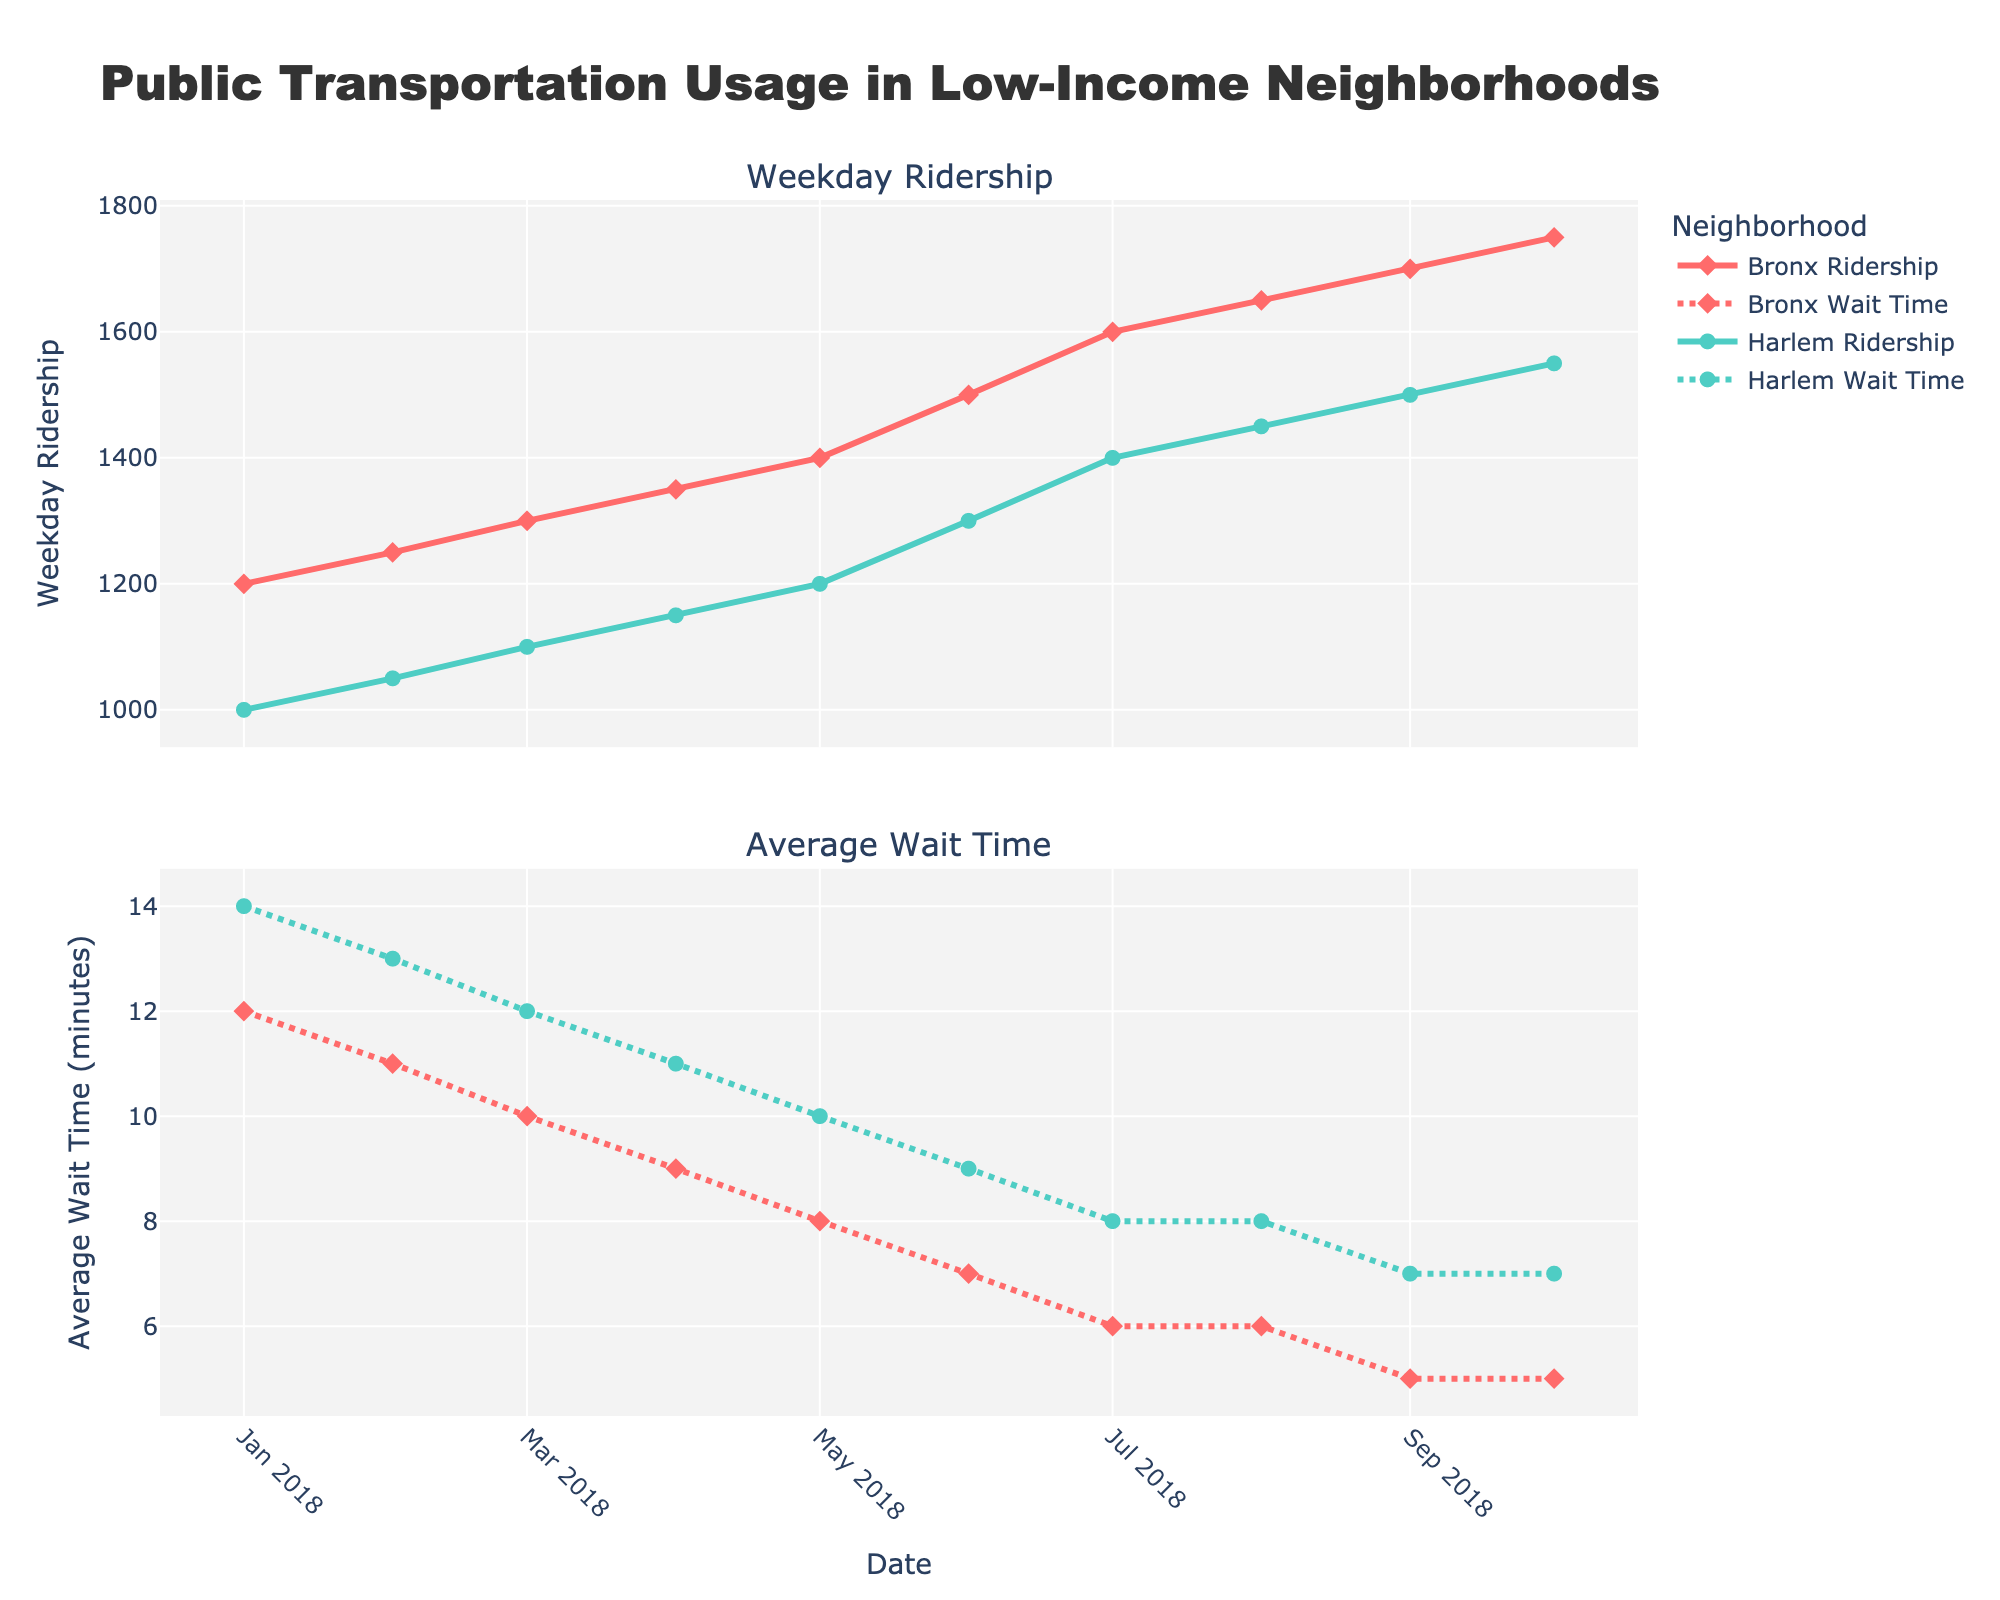What is the title of the plot? The title of the plot is displayed at the top of the figure. It is "Public Transportation Usage in Low-Income Neighborhoods".
Answer: Public Transportation Usage in Low-Income Neighborhoods What is the total number of data points for the Bronx ridership? There are 10 data points shown for the Bronx in the first subplot under "Weekday Ridership". They correspond to each month from January to October 2018.
Answer: 10 How do the average wait times compare between the Bronx and Harlem in July 2018? To compare average wait times, look at the second subplot for July 2018. For the Bronx, the average wait time is 6 minutes, and for Harlem, it is 8 minutes.
Answer: The Bronx has a lower average wait time of 6 minutes, compared to Harlem's 8 minutes Which neighborhood shows a greater increase in weekday ridership from January to October 2018? To determine the increase in weekday ridership, examine the first subplot. In the Bronx, the ridership increases from 1200 to 1750, and in Harlem, it increases from 1000 to 1550. The increase for the Bronx is 550, and for Harlem, it is also 550.
Answer: Both neighborhoods show the same increase of 550 in weekday ridership What is the trend in average wait times for the Bronx from January to October 2018? To identify the trend in average wait times for the Bronx, observe the line in the second subplot for the Bronx. The average wait time decreases from 12 minutes in January to 5 minutes in October, showing a downward trend.
Answer: Downward trend Between the Bronx and Harlem, which neighborhood has higher bus satisfaction in September 2018? Compare the bus satisfaction ratings for September 2018 at the respective data points. For the Bronx, it is 7.8, and for Harlem, it is 7.5.
Answer: The Bronx Calculate the average weekday ridership for Harlem in the first quarter of 2018. The first quarter includes January, February, and March. The weekday ridership values for Harlem are 1000, 1050, and 1100. Their sum is 3150, and the average is calculated by dividing by 3.
Answer: 1050 What pattern is observed in the average wait times for Harlem from March to June 2018? Examine the second subplot and look at the points corresponding to March, April, May, and June. The average wait times decrease each month from 12 minutes in March to 9 minutes in June.
Answer: Decreasing pattern How does bus satisfaction in the Bronx change from January to October 2018? Look at the bus satisfaction data points for the Bronx from January to October 2018. The satisfaction rating increases from 6.5 in January to 8.0 in October. This shows an upward trend.
Answer: Upward trend Is there a month when both neighborhoods have an equal weekday ridership? If so, which month? Cross-reference the data points for both neighborhoods in the first subplot. In no month do the Bronx and Harlem have the same weekday ridership values for the entire period.
Answer: No 